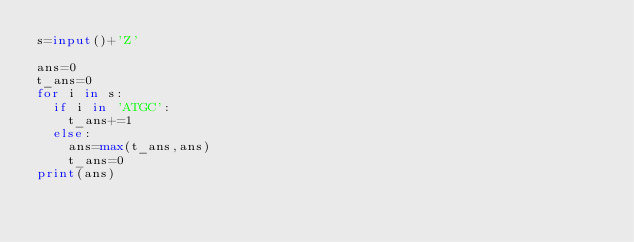<code> <loc_0><loc_0><loc_500><loc_500><_Python_>s=input()+'Z'

ans=0
t_ans=0
for i in s:
  if i in 'ATGC':
    t_ans+=1
  else:
    ans=max(t_ans,ans)
    t_ans=0
print(ans)</code> 